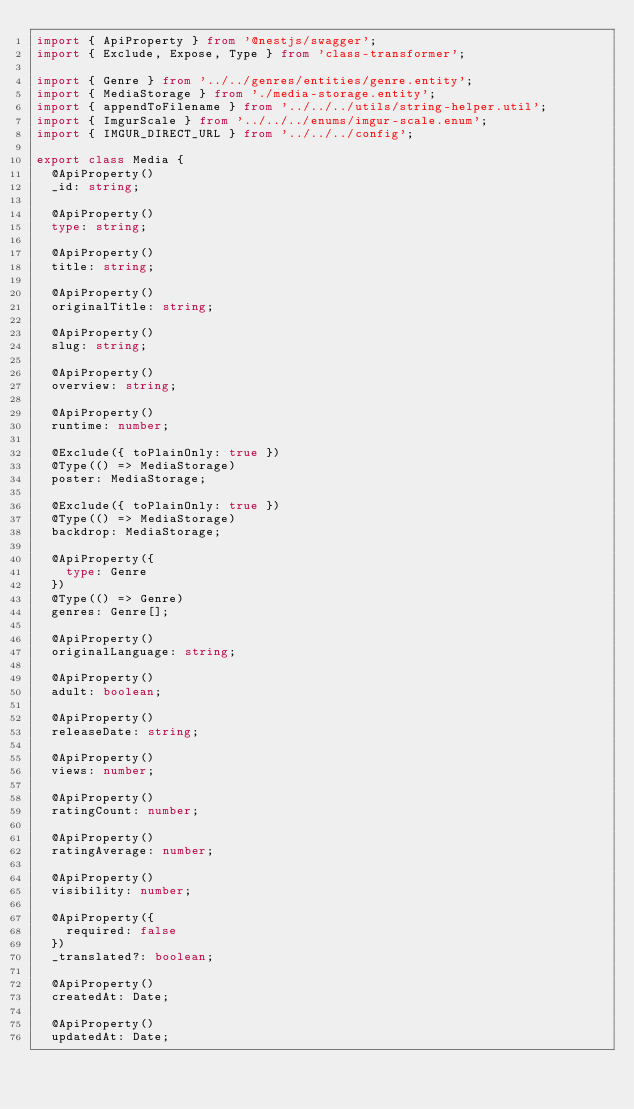Convert code to text. <code><loc_0><loc_0><loc_500><loc_500><_TypeScript_>import { ApiProperty } from '@nestjs/swagger';
import { Exclude, Expose, Type } from 'class-transformer';

import { Genre } from '../../genres/entities/genre.entity';
import { MediaStorage } from './media-storage.entity';
import { appendToFilename } from '../../../utils/string-helper.util';
import { ImgurScale } from '../../../enums/imgur-scale.enum';
import { IMGUR_DIRECT_URL } from '../../../config';

export class Media {
  @ApiProperty()
  _id: string;

  @ApiProperty()
  type: string;

  @ApiProperty()
  title: string;

  @ApiProperty()
  originalTitle: string;

  @ApiProperty()
  slug: string;

  @ApiProperty()
  overview: string;

  @ApiProperty()
  runtime: number;

  @Exclude({ toPlainOnly: true })
  @Type(() => MediaStorage)
  poster: MediaStorage;

  @Exclude({ toPlainOnly: true })
  @Type(() => MediaStorage)
  backdrop: MediaStorage;

  @ApiProperty({
    type: Genre
  })
  @Type(() => Genre)
  genres: Genre[];

  @ApiProperty()
  originalLanguage: string;

  @ApiProperty()
  adult: boolean;

  @ApiProperty()
  releaseDate: string;

  @ApiProperty()
  views: number;

  @ApiProperty()
  ratingCount: number;

  @ApiProperty()
  ratingAverage: number;

  @ApiProperty()
  visibility: number;

  @ApiProperty({
    required: false
  })
  _translated?: boolean;

  @ApiProperty()
  createdAt: Date;

  @ApiProperty()
  updatedAt: Date;
</code> 